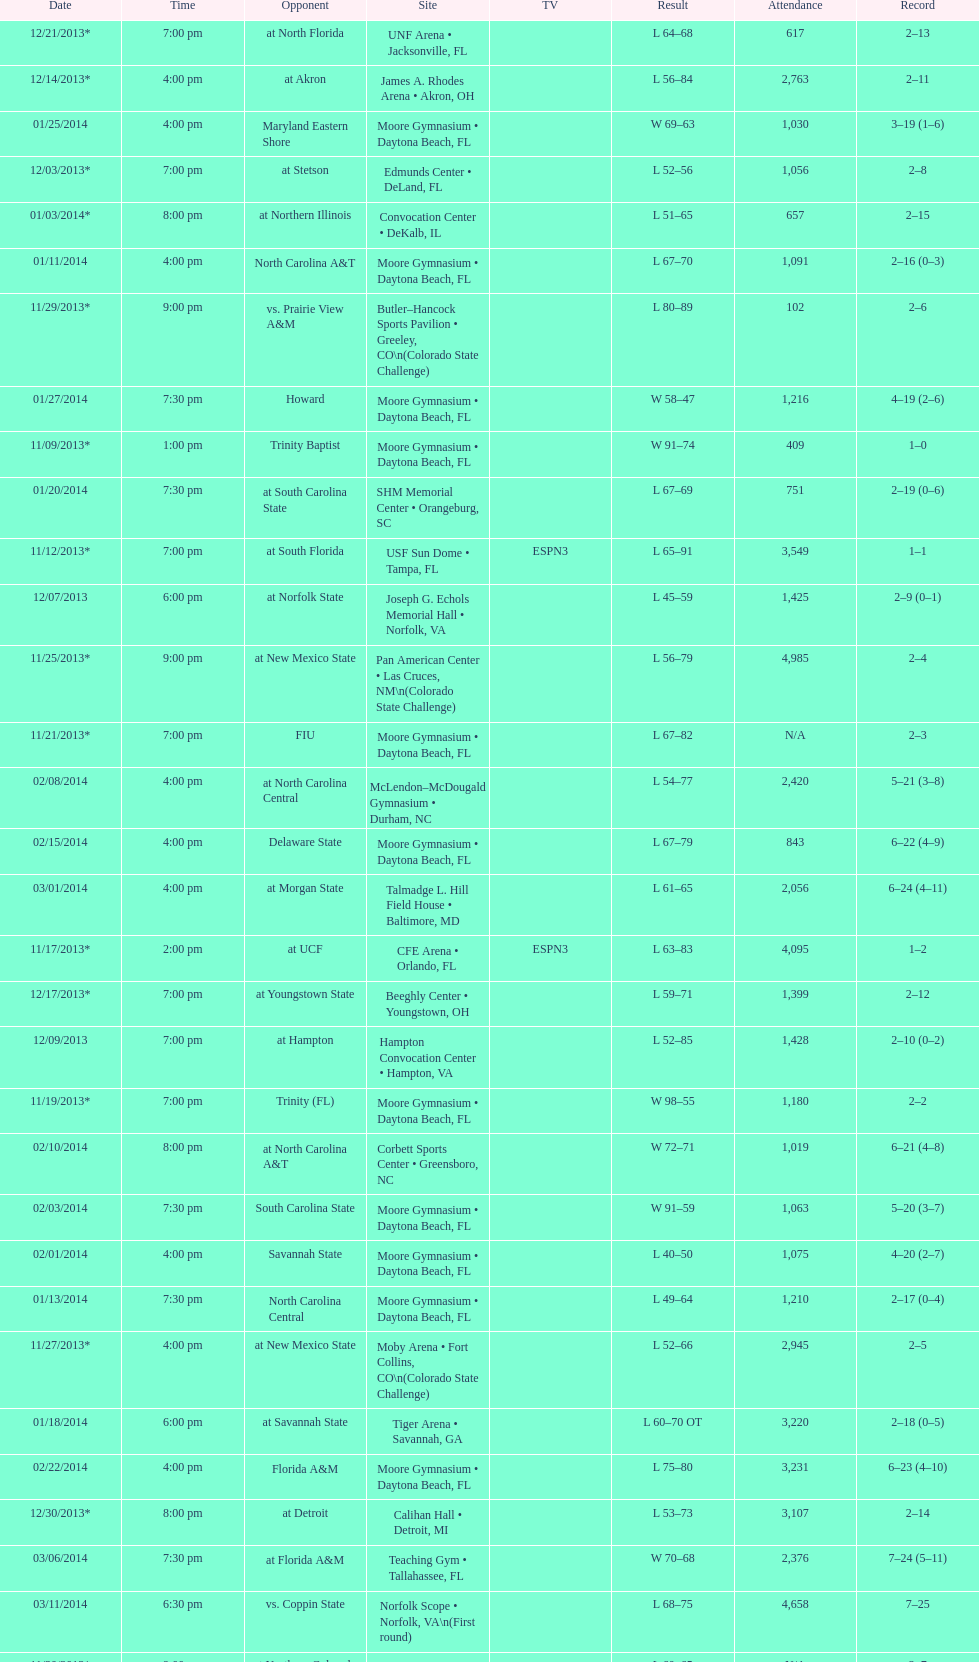How many games did the wildcats play in daytona beach, fl? 11. 